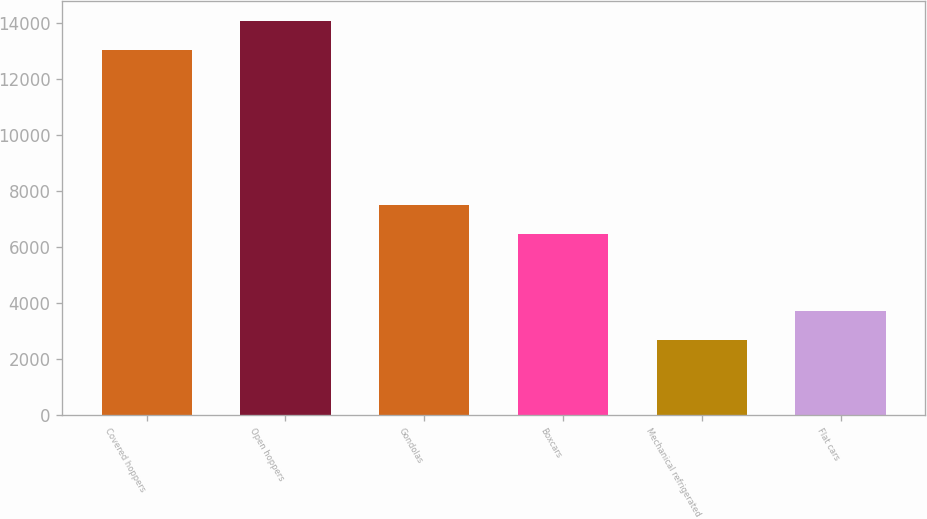Convert chart to OTSL. <chart><loc_0><loc_0><loc_500><loc_500><bar_chart><fcel>Covered hoppers<fcel>Open hoppers<fcel>Gondolas<fcel>Boxcars<fcel>Mechanical refrigerated<fcel>Flat cars<nl><fcel>13053<fcel>14097.8<fcel>7513.8<fcel>6469<fcel>2696<fcel>3740.8<nl></chart> 